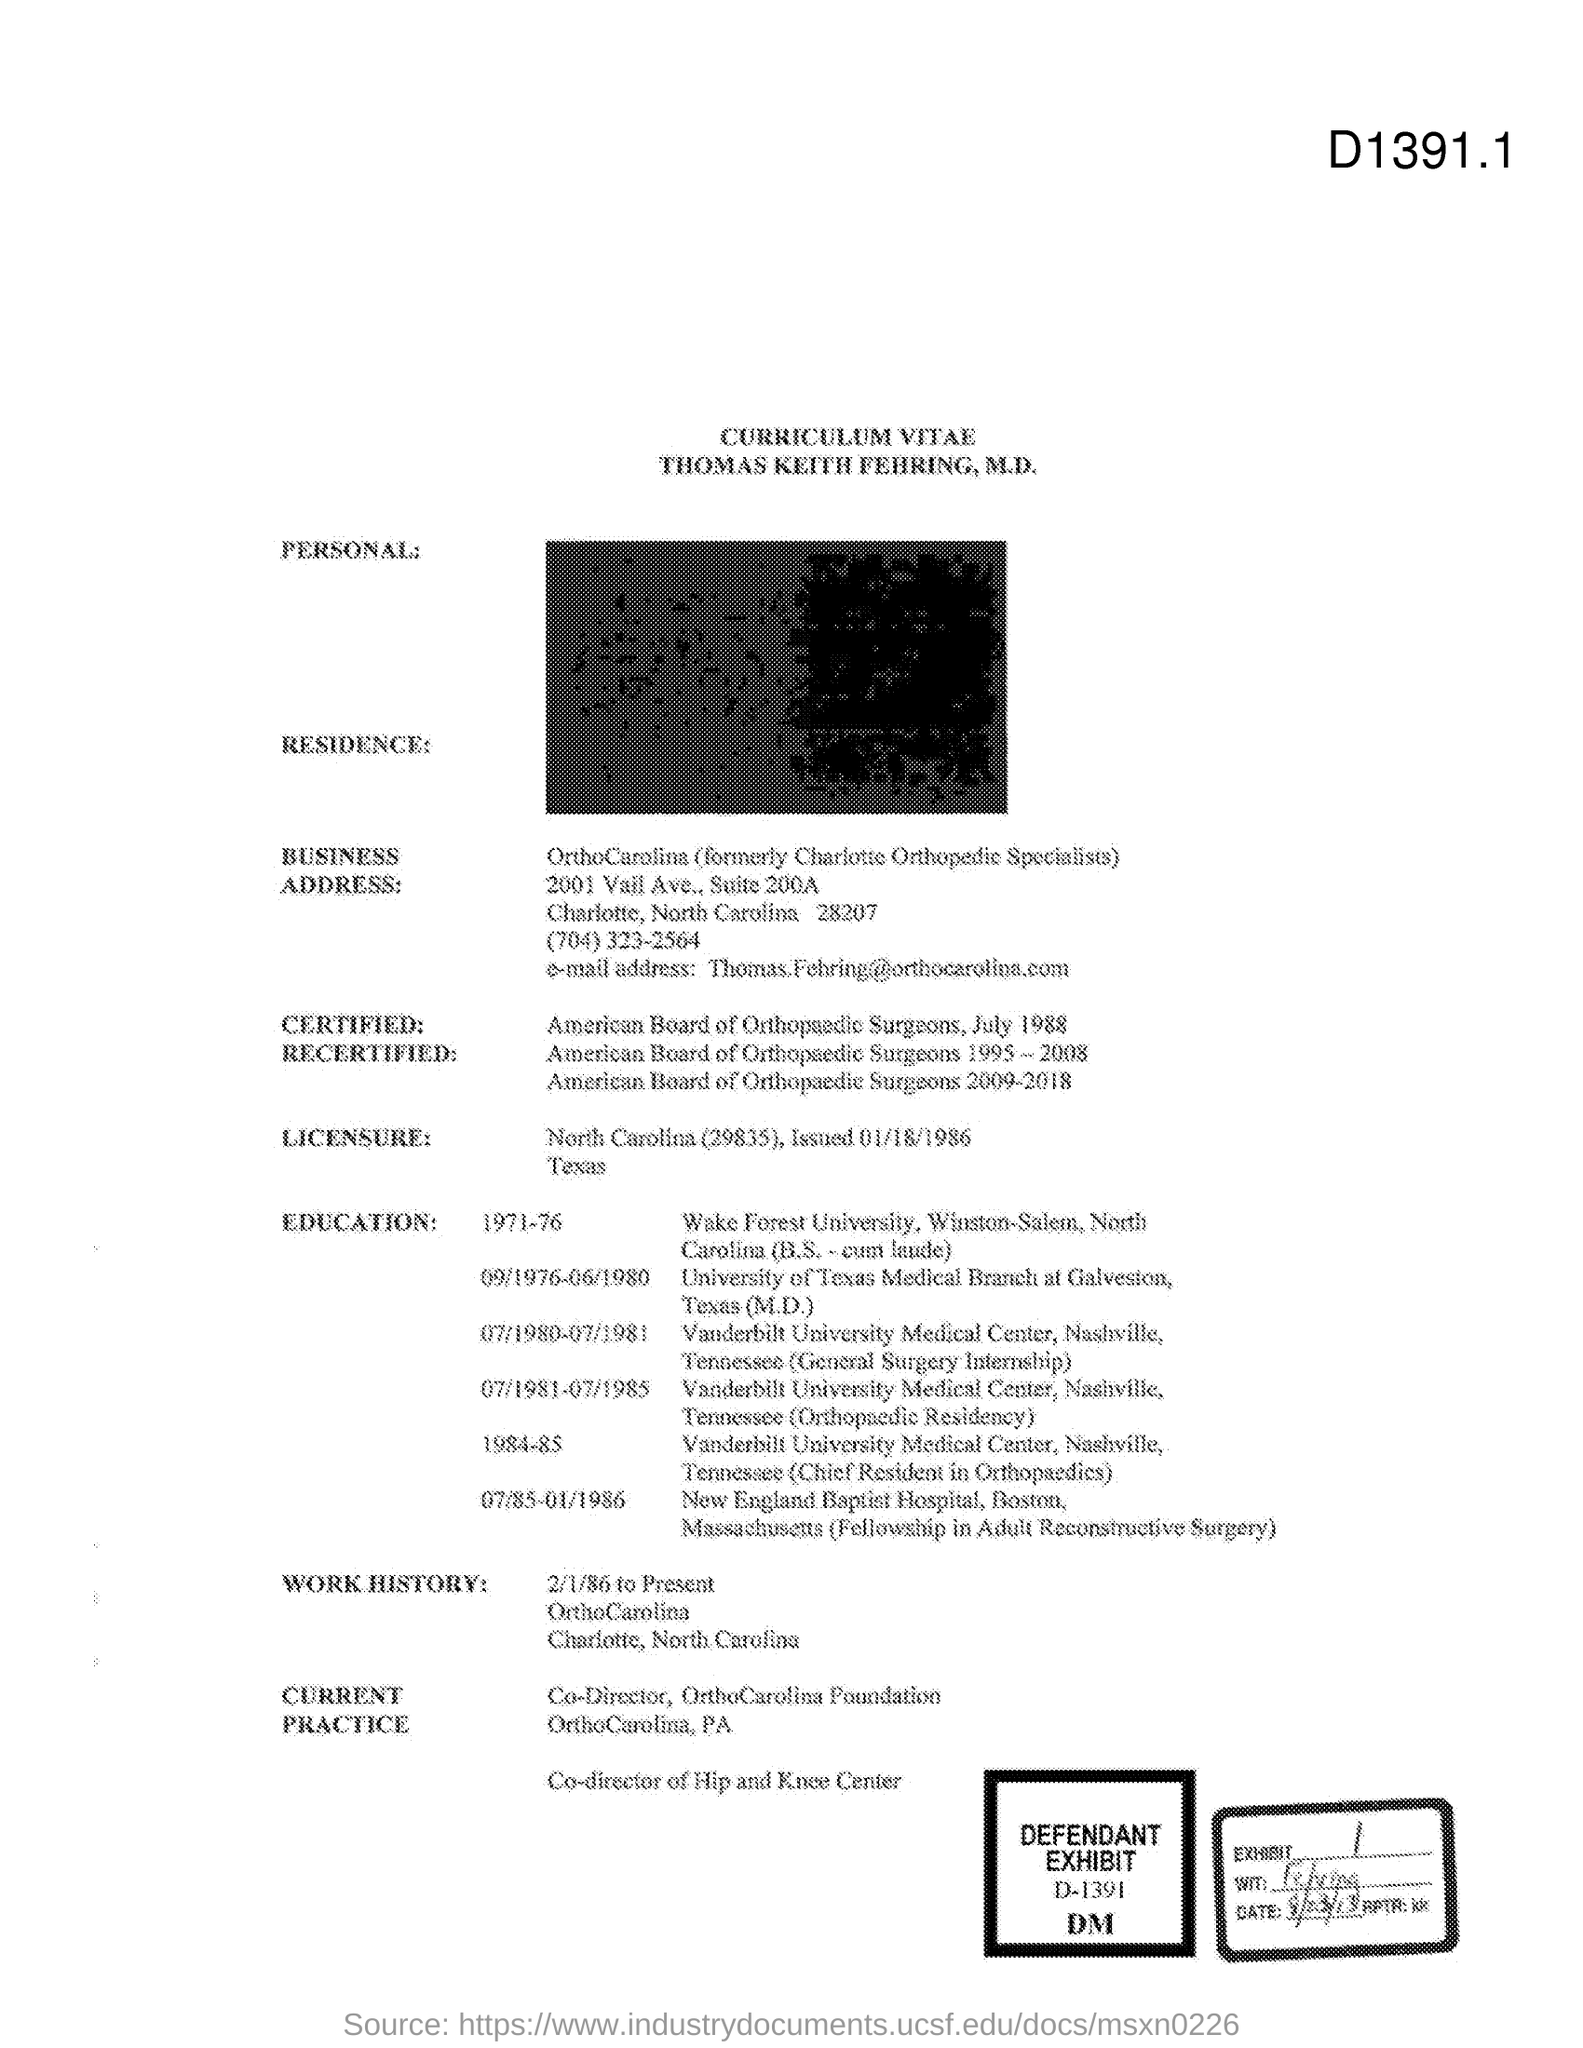What is the Exhibit number?
Your answer should be compact. 1. What is the defendant exhibit number?
Ensure brevity in your answer.  D-1391. 